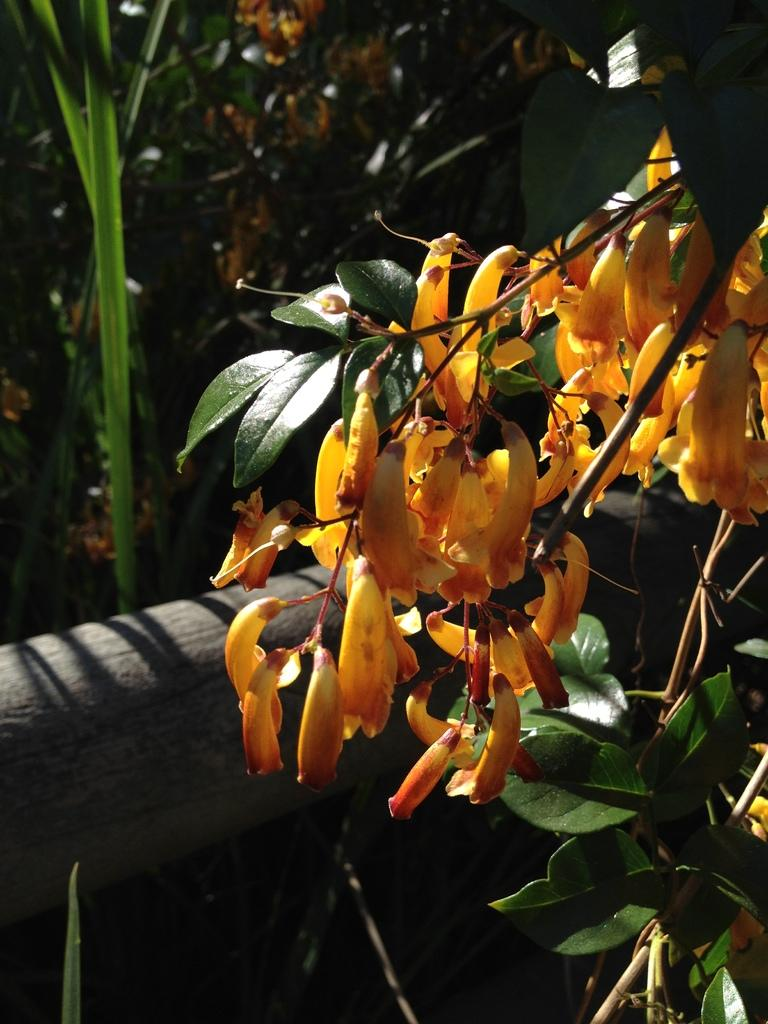What color are the flowers in the image? The flowers in the image are yellow. What is the arrangement of the flowers in the image? The flowers are surrounded by various plants. What type of lettuce can be seen growing among the flowers in the image? There is no lettuce present in the image; it only features flowers and various plants. 